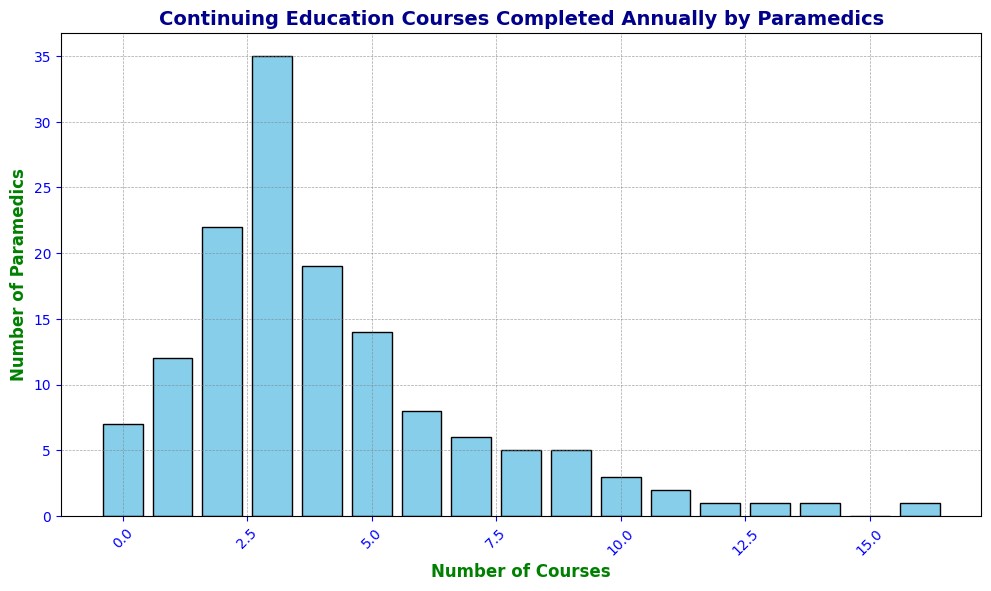What is the mode number of continuing education courses completed annually by paramedics? To find the mode, look for the course number with the highest bar. The bar at '3' has the highest height, indicating the most paramedics completed 3 courses annually.
Answer: 3 What is the total number of paramedics who completed between 4 and 6 courses (inclusive) annually? Add the values for the courses 4, 5, and 6: 19 (for 4 courses) + 14 (for 5 courses) + 8 (for 6 courses) = 41.
Answer: 41 Between which numbers of continuing education courses is there the greatest drop in the number of paramedics? Identify the largest difference by comparing the heights of adjacent bars. The biggest drop is between 3 and 4 courses: 35 (for 3 courses) - 19 (for 4 courses) = 16.
Answer: Between 3 and 4 courses How many more paramedics completed 3 courses annually compared to 2 courses annually? Subtract the number of paramedics completing 2 courses from those completing 3 courses: 35 (for 3 courses) - 22 (for 2 courses) = 13.
Answer: 13 Which course numbers have an equal number of paramedics completing them annually? Look for bars of equal height. Both the '8' and '9' course numbers have bars indicating 5 paramedics each completed these courses annually.
Answer: 8 and 9 What is the total number of paramedics who completed more than 5 courses annually? Add the counts of paramedics for course numbers greater than 5: 8 (for 6) + 6 (for 7) + 5 (for 8) + 5 (for 9) + 3 (for 10) + 2 (for 11) + 1 (each for 12, 13, 14, and 16). The total is 32.
Answer: 32 What is the median number of continuing education courses completed annually by paramedics? To find the median, list all the counts and identify the middle value. The counts are: 7, 12, 22, 35, 19, 14, 8, 6, 5, 5, 3, 2, 1, 1, 1, 0, 1.
The cumulative paramedics count until the median is reached: 7 + 12 + 22 + 35 = 76 (since the total number of paramedics is 91, the median will be around the middle of this cumulative count). Thus, the median lies at 3.
Answer: 3 